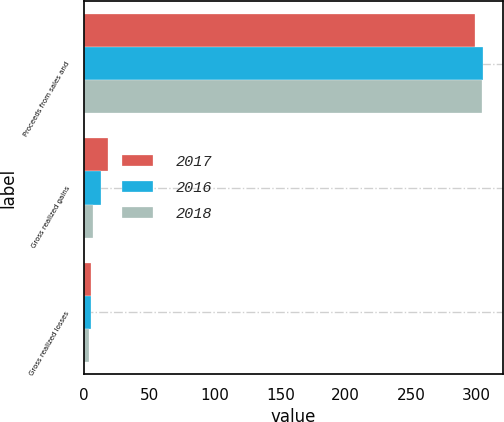<chart> <loc_0><loc_0><loc_500><loc_500><stacked_bar_chart><ecel><fcel>Proceeds from sales and<fcel>Gross realized gains<fcel>Gross realized losses<nl><fcel>2017<fcel>299<fcel>18<fcel>5<nl><fcel>2016<fcel>305<fcel>13<fcel>5<nl><fcel>2018<fcel>304<fcel>7<fcel>4<nl></chart> 